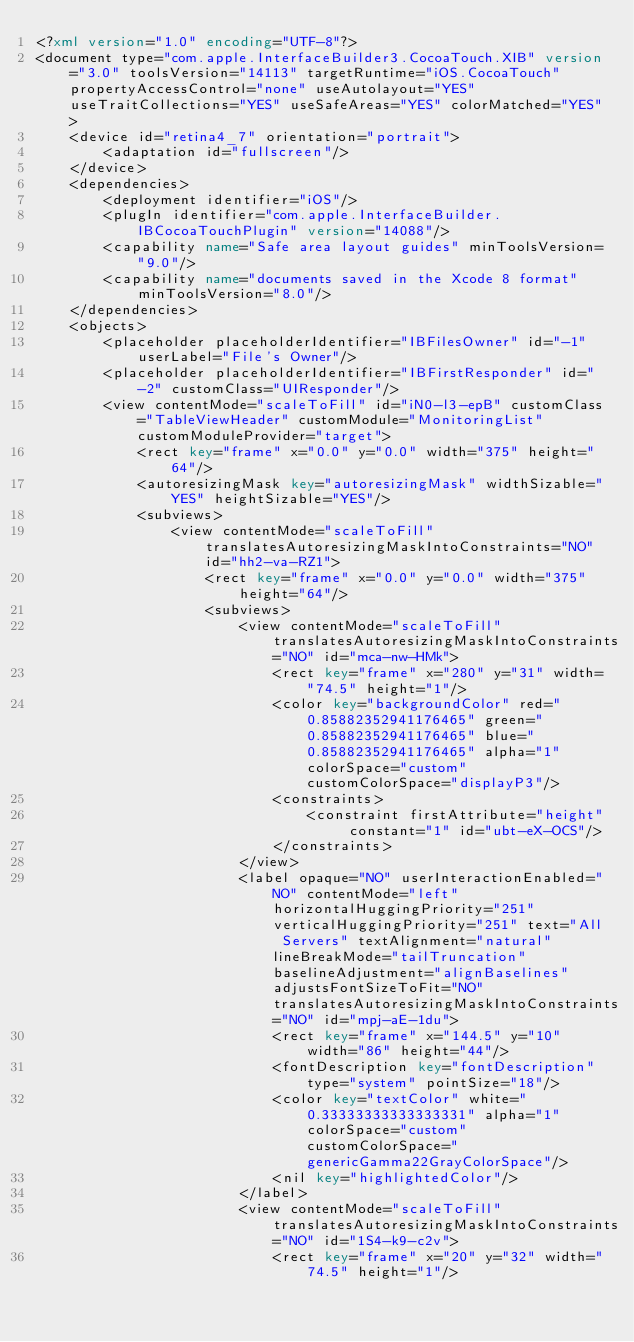Convert code to text. <code><loc_0><loc_0><loc_500><loc_500><_XML_><?xml version="1.0" encoding="UTF-8"?>
<document type="com.apple.InterfaceBuilder3.CocoaTouch.XIB" version="3.0" toolsVersion="14113" targetRuntime="iOS.CocoaTouch" propertyAccessControl="none" useAutolayout="YES" useTraitCollections="YES" useSafeAreas="YES" colorMatched="YES">
    <device id="retina4_7" orientation="portrait">
        <adaptation id="fullscreen"/>
    </device>
    <dependencies>
        <deployment identifier="iOS"/>
        <plugIn identifier="com.apple.InterfaceBuilder.IBCocoaTouchPlugin" version="14088"/>
        <capability name="Safe area layout guides" minToolsVersion="9.0"/>
        <capability name="documents saved in the Xcode 8 format" minToolsVersion="8.0"/>
    </dependencies>
    <objects>
        <placeholder placeholderIdentifier="IBFilesOwner" id="-1" userLabel="File's Owner"/>
        <placeholder placeholderIdentifier="IBFirstResponder" id="-2" customClass="UIResponder"/>
        <view contentMode="scaleToFill" id="iN0-l3-epB" customClass="TableViewHeader" customModule="MonitoringList" customModuleProvider="target">
            <rect key="frame" x="0.0" y="0.0" width="375" height="64"/>
            <autoresizingMask key="autoresizingMask" widthSizable="YES" heightSizable="YES"/>
            <subviews>
                <view contentMode="scaleToFill" translatesAutoresizingMaskIntoConstraints="NO" id="hh2-va-RZ1">
                    <rect key="frame" x="0.0" y="0.0" width="375" height="64"/>
                    <subviews>
                        <view contentMode="scaleToFill" translatesAutoresizingMaskIntoConstraints="NO" id="mca-nw-HMk">
                            <rect key="frame" x="280" y="31" width="74.5" height="1"/>
                            <color key="backgroundColor" red="0.85882352941176465" green="0.85882352941176465" blue="0.85882352941176465" alpha="1" colorSpace="custom" customColorSpace="displayP3"/>
                            <constraints>
                                <constraint firstAttribute="height" constant="1" id="ubt-eX-OCS"/>
                            </constraints>
                        </view>
                        <label opaque="NO" userInteractionEnabled="NO" contentMode="left" horizontalHuggingPriority="251" verticalHuggingPriority="251" text="All Servers" textAlignment="natural" lineBreakMode="tailTruncation" baselineAdjustment="alignBaselines" adjustsFontSizeToFit="NO" translatesAutoresizingMaskIntoConstraints="NO" id="mpj-aE-1du">
                            <rect key="frame" x="144.5" y="10" width="86" height="44"/>
                            <fontDescription key="fontDescription" type="system" pointSize="18"/>
                            <color key="textColor" white="0.33333333333333331" alpha="1" colorSpace="custom" customColorSpace="genericGamma22GrayColorSpace"/>
                            <nil key="highlightedColor"/>
                        </label>
                        <view contentMode="scaleToFill" translatesAutoresizingMaskIntoConstraints="NO" id="1S4-k9-c2v">
                            <rect key="frame" x="20" y="32" width="74.5" height="1"/></code> 